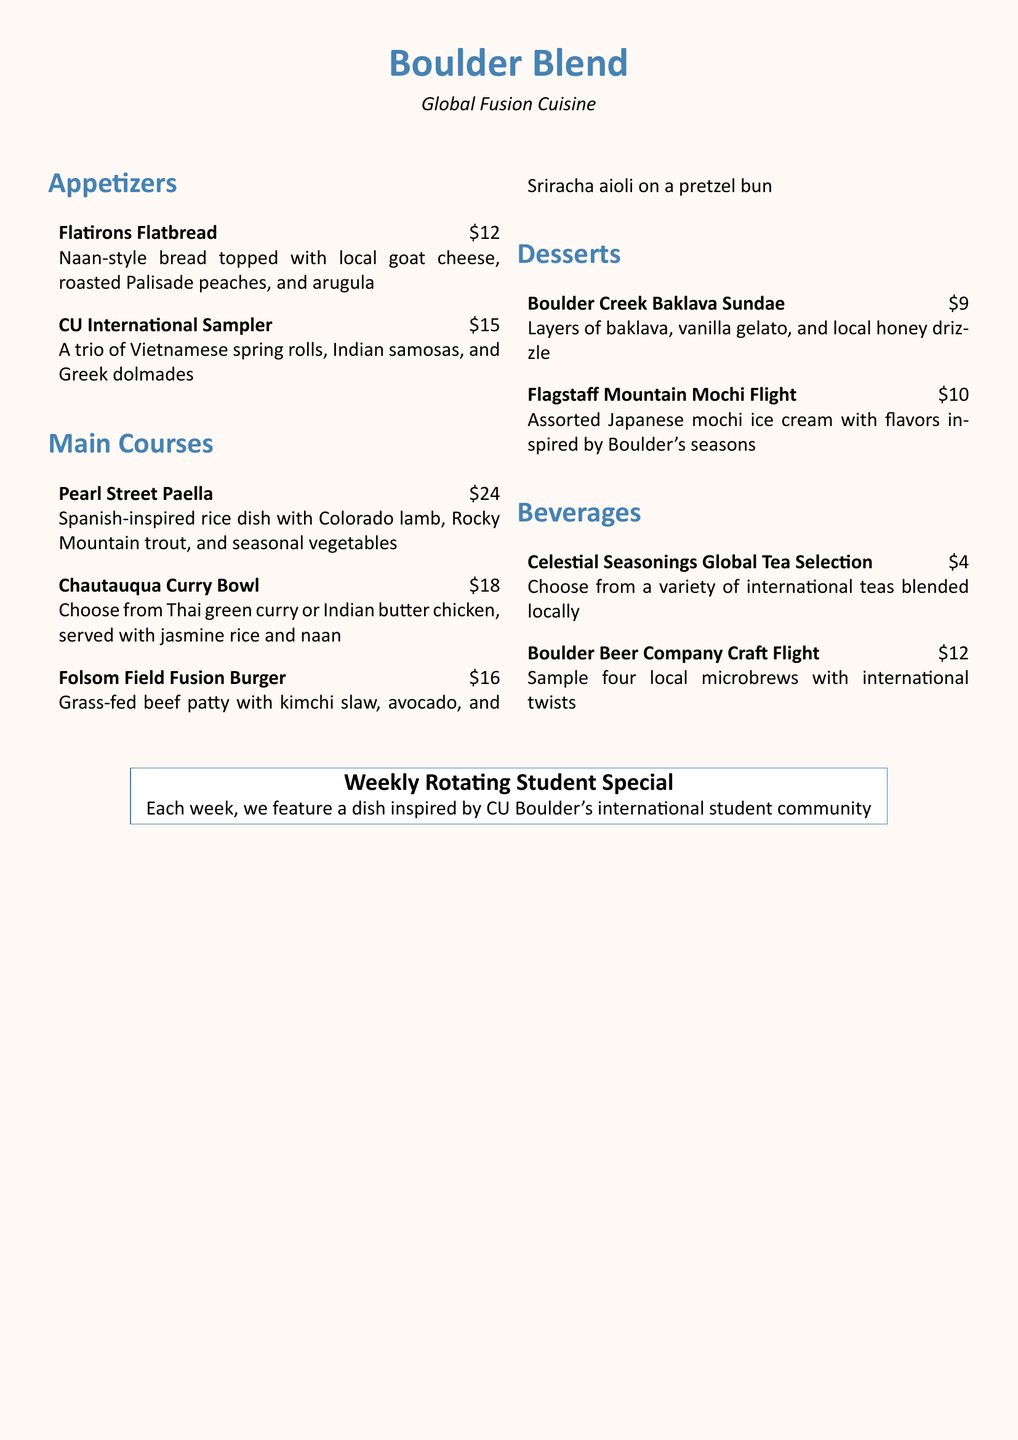What is the name of the appetizer featuring naan-style bread? The document states the appetizer is called "Flatirons Flatbread."
Answer: Flatirons Flatbread How much does the CU International Sampler cost? The menu lists the price of the CU International Sampler as $15.
Answer: $15 What types of cuisine are represented in the CU International Sampler? The document mentions Vietnamese, Indian, and Greek cuisines in the CU International Sampler.
Answer: Vietnamese, Indian, Greek What is the main protein in the Pearl Street Paella? The menu indicates that it includes Colorado lamb as one of the main proteins.
Answer: Colorado lamb Which dish has a kimchi slaw? The Folsom Field Fusion Burger is the dish that includes kimchi slaw.
Answer: Folsom Field Fusion Burger What special feature does the restaurant offer weekly? The weekly feature is a dish inspired by CU Boulder's international student community.
Answer: Weekly Rotating Student Special Which dessert includes vanilla gelato? The Boulder Creek Baklava Sundae is the dessert that includes vanilla gelato.
Answer: Boulder Creek Baklava Sundae What is the price of the Boulder Beer Company Craft Flight? The document shows the price for the Boulder Beer Company Craft Flight is $12.
Answer: $12 How many flavors are included in the Flagstaff Mountain Mochi Flight? The menu does not specify the exact number of flavors but suggests a variety is included.
Answer: Assorted 